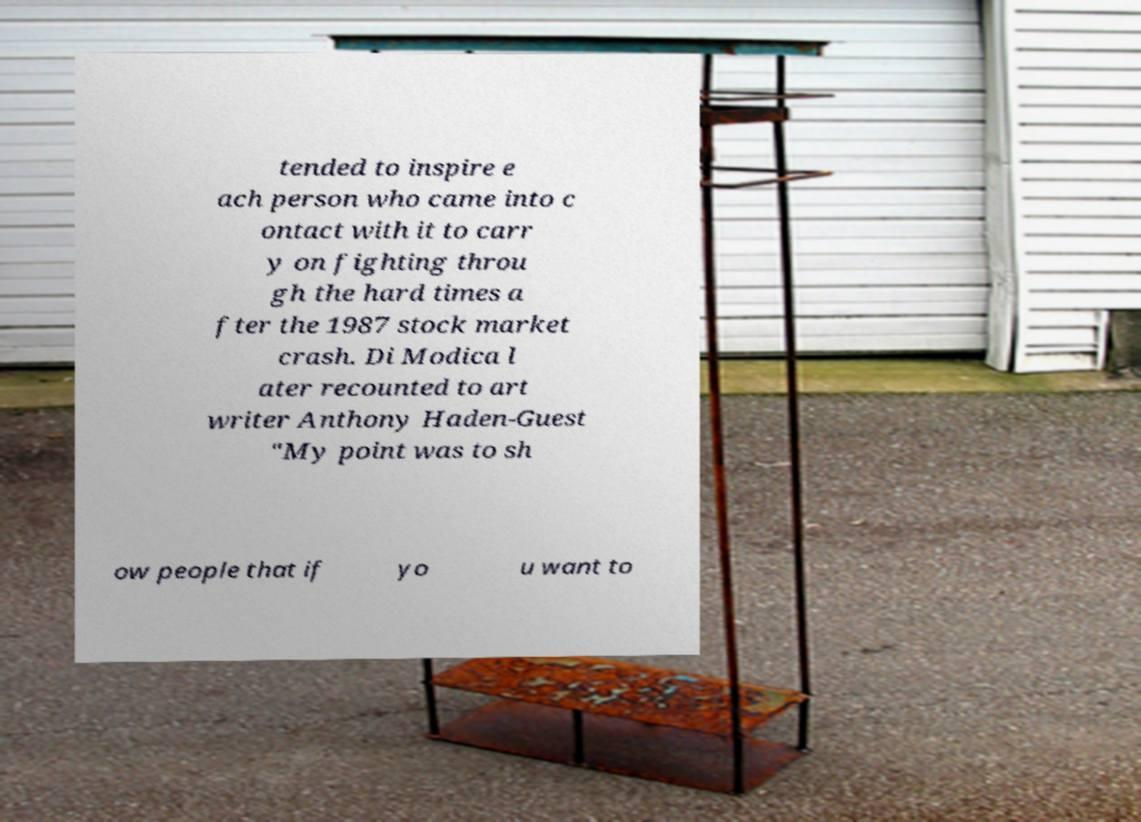Can you read and provide the text displayed in the image?This photo seems to have some interesting text. Can you extract and type it out for me? tended to inspire e ach person who came into c ontact with it to carr y on fighting throu gh the hard times a fter the 1987 stock market crash. Di Modica l ater recounted to art writer Anthony Haden-Guest "My point was to sh ow people that if yo u want to 